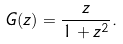<formula> <loc_0><loc_0><loc_500><loc_500>G ( z ) = \frac { z } { 1 + z ^ { 2 } } .</formula> 